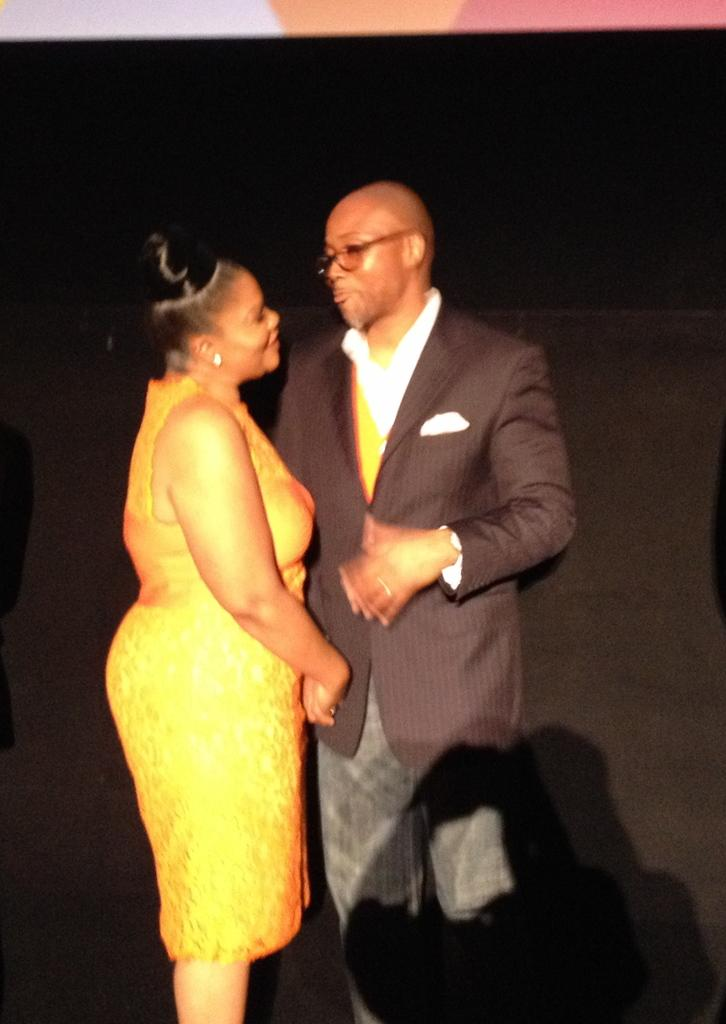How many people are in the image? There are two people in the image, a man and a woman. What are the man and woman doing in the image? The man and woman are standing and shaking hands. What type of transport is visible in the image? There is no transport visible in the image; it features a man and a woman shaking hands. What verse is being recited by the man in the image? There is no verse being recited in the image; the man and woman are simply shaking hands. 